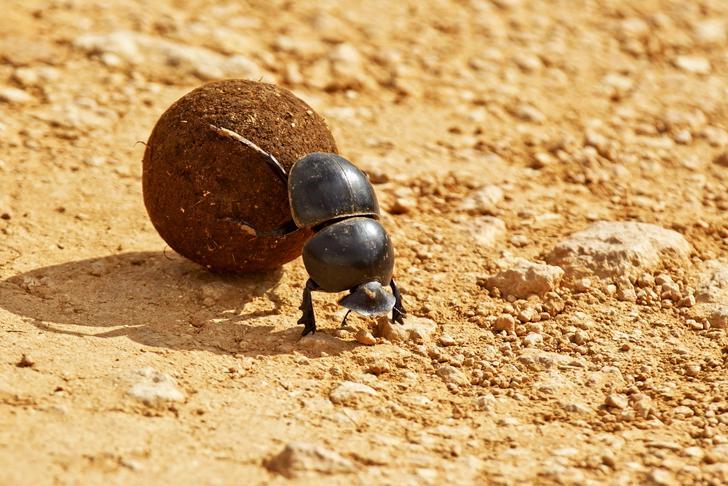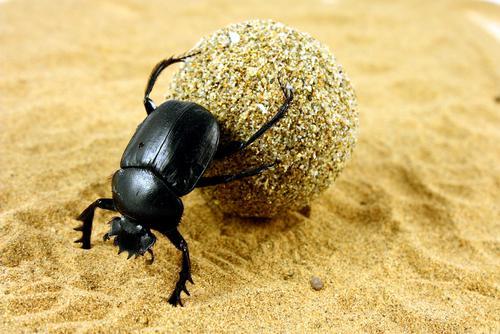The first image is the image on the left, the second image is the image on the right. Given the left and right images, does the statement "Each image shows just one beetle in contact with one round dung ball." hold true? Answer yes or no. Yes. 